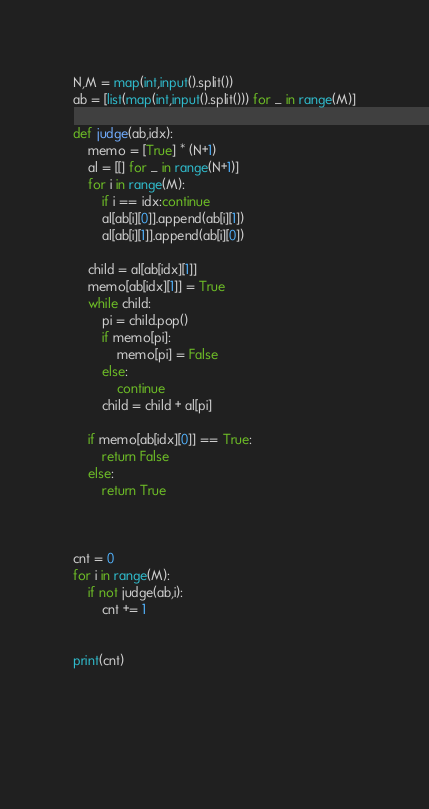<code> <loc_0><loc_0><loc_500><loc_500><_Python_>N,M = map(int,input().split())
ab = [list(map(int,input().split())) for _ in range(M)]

def judge(ab,idx):
    memo = [True] * (N+1)
    al = [[] for _ in range(N+1)]
    for i in range(M):
        if i == idx:continue
        al[ab[i][0]].append(ab[i][1])
        al[ab[i][1]].append(ab[i][0])
            
    child = al[ab[idx][1]]
    memo[ab[idx][1]] = True
    while child:
        pi = child.pop()
        if memo[pi]:
            memo[pi] = False
        else:
            continue
        child = child + al[pi]
        
    if memo[ab[idx][0]] == True:
        return False
    else:
        return True
    
    
    
cnt = 0
for i in range(M):
    if not judge(ab,i):
        cnt += 1
        

print(cnt)
    
    
    
    
</code> 